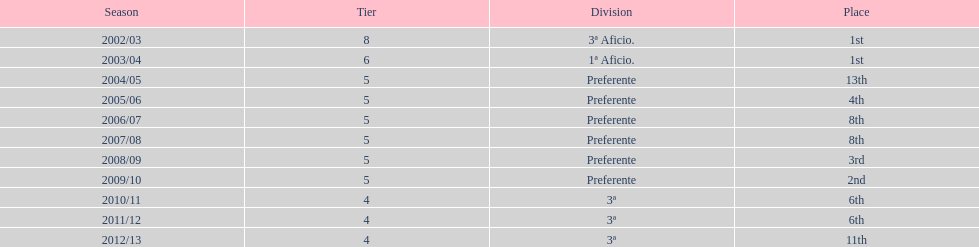In what year was the team's ranking identical to their 2010/11 standing? 2011/12. 